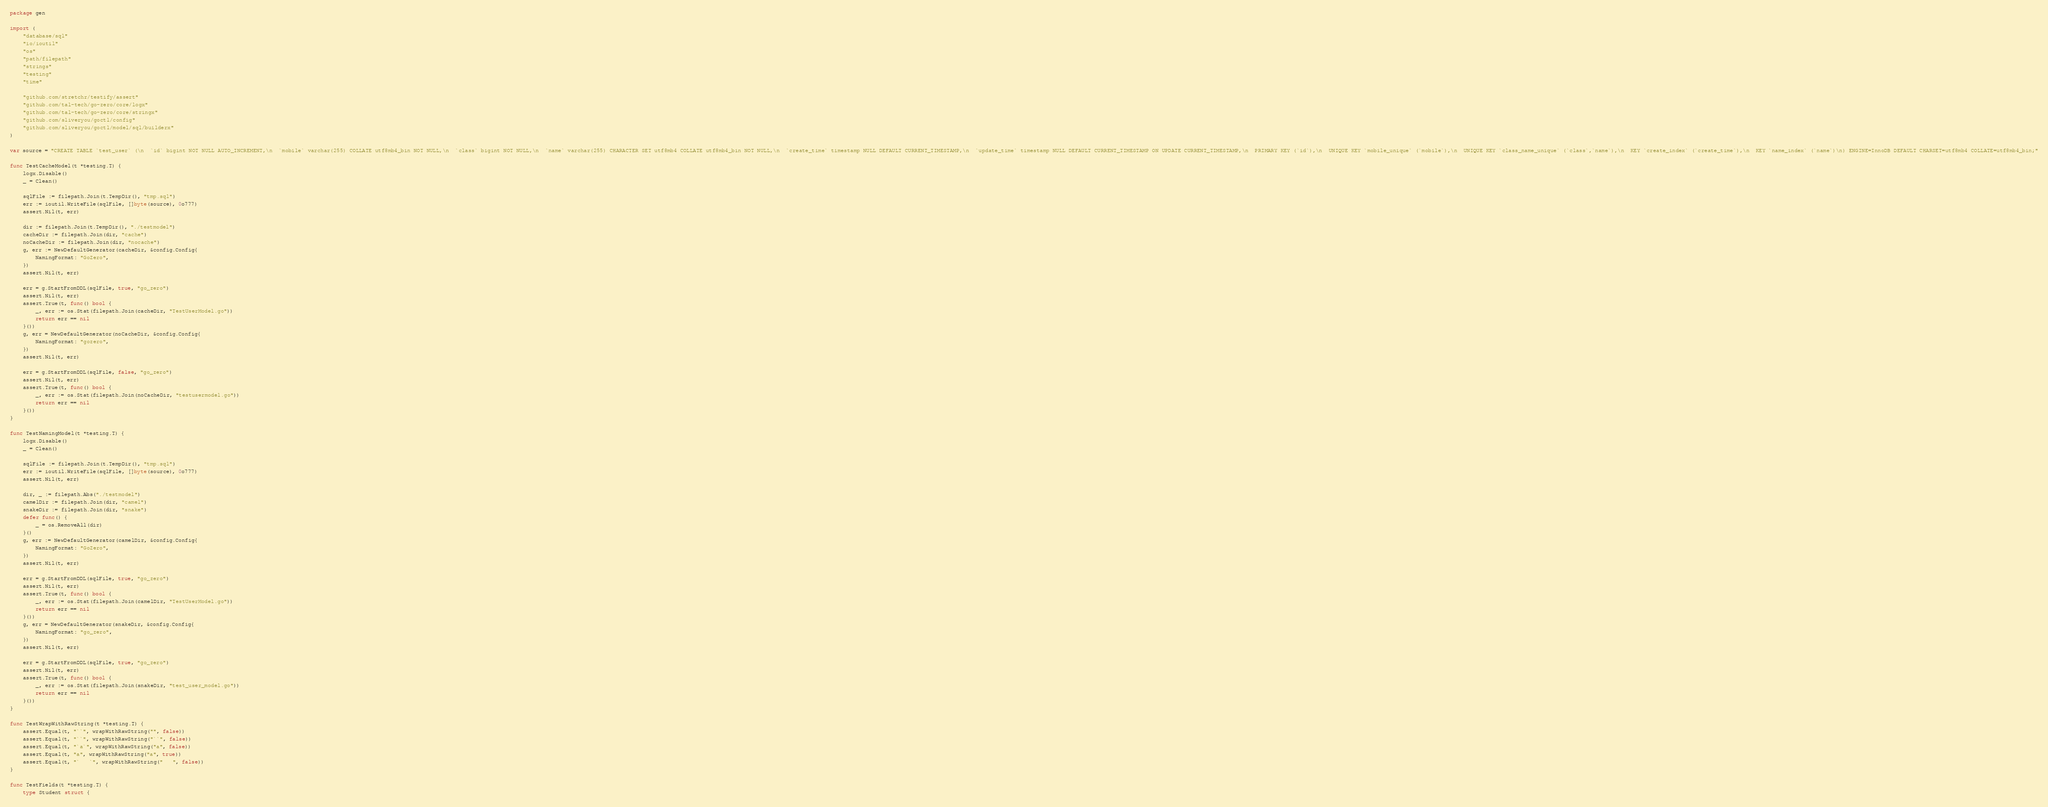Convert code to text. <code><loc_0><loc_0><loc_500><loc_500><_Go_>package gen

import (
	"database/sql"
	"io/ioutil"
	"os"
	"path/filepath"
	"strings"
	"testing"
	"time"

	"github.com/stretchr/testify/assert"
	"github.com/tal-tech/go-zero/core/logx"
	"github.com/tal-tech/go-zero/core/stringx"
	"github.com/sliveryou/goctl/config"
	"github.com/sliveryou/goctl/model/sql/builderx"
)

var source = "CREATE TABLE `test_user` (\n  `id` bigint NOT NULL AUTO_INCREMENT,\n  `mobile` varchar(255) COLLATE utf8mb4_bin NOT NULL,\n  `class` bigint NOT NULL,\n  `name` varchar(255) CHARACTER SET utf8mb4 COLLATE utf8mb4_bin NOT NULL,\n  `create_time` timestamp NULL DEFAULT CURRENT_TIMESTAMP,\n  `update_time` timestamp NULL DEFAULT CURRENT_TIMESTAMP ON UPDATE CURRENT_TIMESTAMP,\n  PRIMARY KEY (`id`),\n  UNIQUE KEY `mobile_unique` (`mobile`),\n  UNIQUE KEY `class_name_unique` (`class`,`name`),\n  KEY `create_index` (`create_time`),\n  KEY `name_index` (`name`)\n) ENGINE=InnoDB DEFAULT CHARSET=utf8mb4 COLLATE=utf8mb4_bin;"

func TestCacheModel(t *testing.T) {
	logx.Disable()
	_ = Clean()

	sqlFile := filepath.Join(t.TempDir(), "tmp.sql")
	err := ioutil.WriteFile(sqlFile, []byte(source), 0o777)
	assert.Nil(t, err)

	dir := filepath.Join(t.TempDir(), "./testmodel")
	cacheDir := filepath.Join(dir, "cache")
	noCacheDir := filepath.Join(dir, "nocache")
	g, err := NewDefaultGenerator(cacheDir, &config.Config{
		NamingFormat: "GoZero",
	})
	assert.Nil(t, err)

	err = g.StartFromDDL(sqlFile, true, "go_zero")
	assert.Nil(t, err)
	assert.True(t, func() bool {
		_, err := os.Stat(filepath.Join(cacheDir, "TestUserModel.go"))
		return err == nil
	}())
	g, err = NewDefaultGenerator(noCacheDir, &config.Config{
		NamingFormat: "gozero",
	})
	assert.Nil(t, err)

	err = g.StartFromDDL(sqlFile, false, "go_zero")
	assert.Nil(t, err)
	assert.True(t, func() bool {
		_, err := os.Stat(filepath.Join(noCacheDir, "testusermodel.go"))
		return err == nil
	}())
}

func TestNamingModel(t *testing.T) {
	logx.Disable()
	_ = Clean()

	sqlFile := filepath.Join(t.TempDir(), "tmp.sql")
	err := ioutil.WriteFile(sqlFile, []byte(source), 0o777)
	assert.Nil(t, err)

	dir, _ := filepath.Abs("./testmodel")
	camelDir := filepath.Join(dir, "camel")
	snakeDir := filepath.Join(dir, "snake")
	defer func() {
		_ = os.RemoveAll(dir)
	}()
	g, err := NewDefaultGenerator(camelDir, &config.Config{
		NamingFormat: "GoZero",
	})
	assert.Nil(t, err)

	err = g.StartFromDDL(sqlFile, true, "go_zero")
	assert.Nil(t, err)
	assert.True(t, func() bool {
		_, err := os.Stat(filepath.Join(camelDir, "TestUserModel.go"))
		return err == nil
	}())
	g, err = NewDefaultGenerator(snakeDir, &config.Config{
		NamingFormat: "go_zero",
	})
	assert.Nil(t, err)

	err = g.StartFromDDL(sqlFile, true, "go_zero")
	assert.Nil(t, err)
	assert.True(t, func() bool {
		_, err := os.Stat(filepath.Join(snakeDir, "test_user_model.go"))
		return err == nil
	}())
}

func TestWrapWithRawString(t *testing.T) {
	assert.Equal(t, "``", wrapWithRawString("", false))
	assert.Equal(t, "``", wrapWithRawString("``", false))
	assert.Equal(t, "`a`", wrapWithRawString("a", false))
	assert.Equal(t, "a", wrapWithRawString("a", true))
	assert.Equal(t, "`   `", wrapWithRawString("   ", false))
}

func TestFields(t *testing.T) {
	type Student struct {</code> 